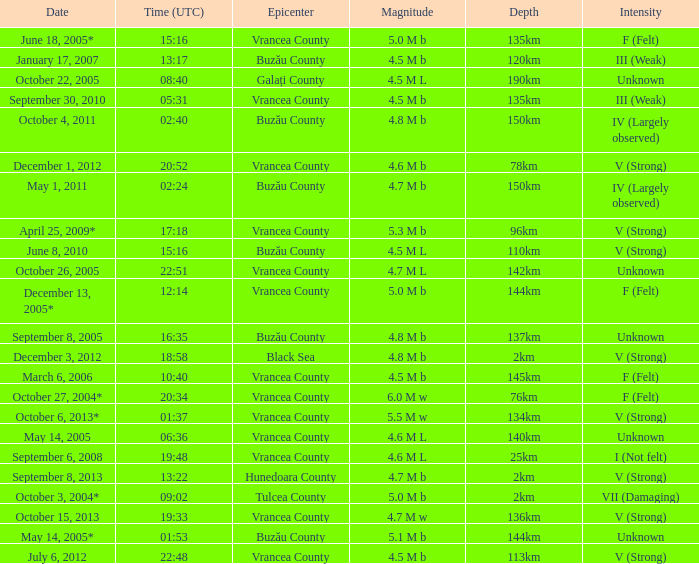What is the magnitude with epicenter at Vrancea County, unknown intensity and which happened at 06:36? 4.6 M L. 